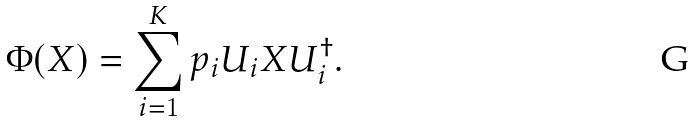Convert formula to latex. <formula><loc_0><loc_0><loc_500><loc_500>\Phi ( X ) = \sum _ { i = 1 } ^ { K } p _ { i } U _ { i } X U _ { i } ^ { \dagger } .</formula> 